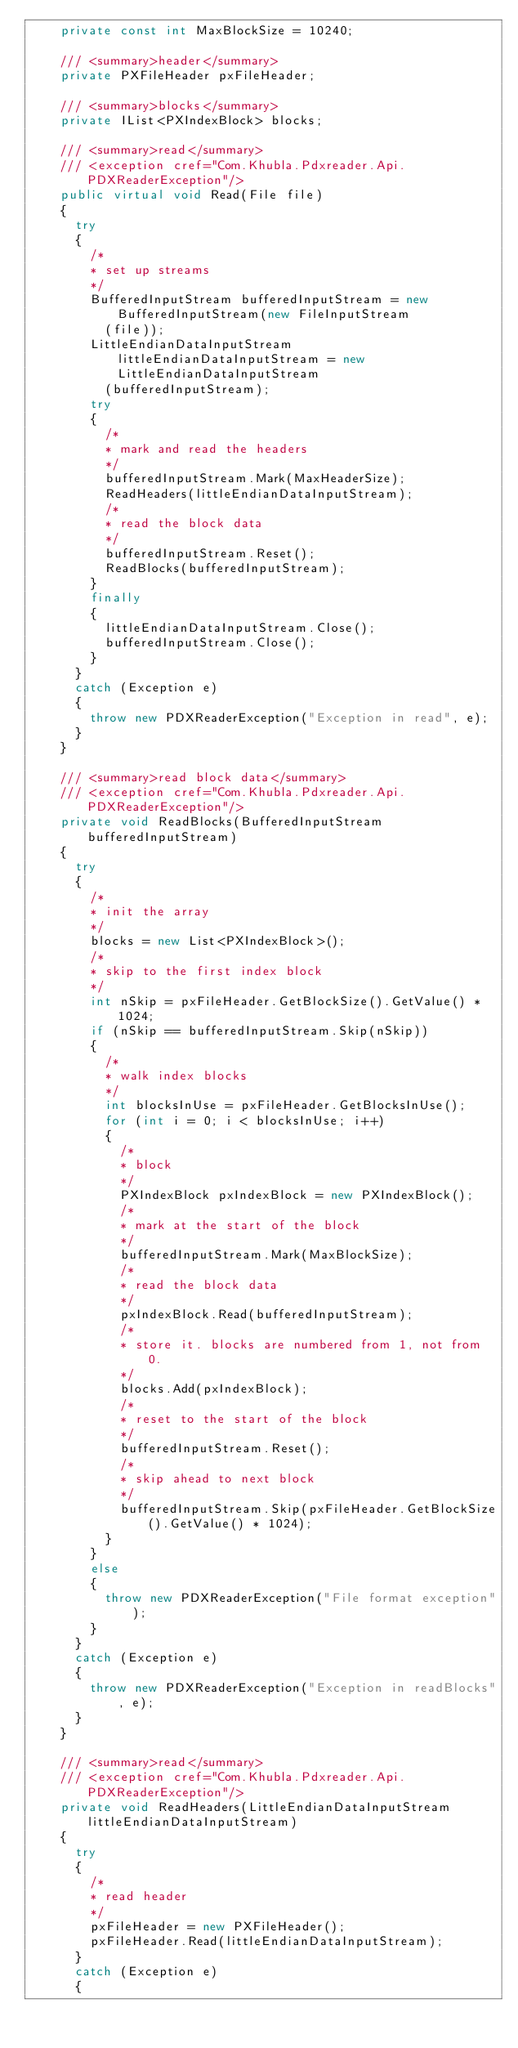<code> <loc_0><loc_0><loc_500><loc_500><_C#_>		private const int MaxBlockSize = 10240;

		/// <summary>header</summary>
		private PXFileHeader pxFileHeader;

		/// <summary>blocks</summary>
		private IList<PXIndexBlock> blocks;

		/// <summary>read</summary>
		/// <exception cref="Com.Khubla.Pdxreader.Api.PDXReaderException"/>
		public virtual void Read(File file)
		{
			try
			{
				/*
				* set up streams
				*/
				BufferedInputStream bufferedInputStream = new BufferedInputStream(new FileInputStream
					(file));
				LittleEndianDataInputStream littleEndianDataInputStream = new LittleEndianDataInputStream
					(bufferedInputStream);
				try
				{
					/*
					* mark and read the headers
					*/
					bufferedInputStream.Mark(MaxHeaderSize);
					ReadHeaders(littleEndianDataInputStream);
					/*
					* read the block data
					*/
					bufferedInputStream.Reset();
					ReadBlocks(bufferedInputStream);
				}
				finally
				{
					littleEndianDataInputStream.Close();
					bufferedInputStream.Close();
				}
			}
			catch (Exception e)
			{
				throw new PDXReaderException("Exception in read", e);
			}
		}

		/// <summary>read block data</summary>
		/// <exception cref="Com.Khubla.Pdxreader.Api.PDXReaderException"/>
		private void ReadBlocks(BufferedInputStream bufferedInputStream)
		{
			try
			{
				/*
				* init the array
				*/
				blocks = new List<PXIndexBlock>();
				/*
				* skip to the first index block
				*/
				int nSkip = pxFileHeader.GetBlockSize().GetValue() * 1024;
				if (nSkip == bufferedInputStream.Skip(nSkip))
				{
					/*
					* walk index blocks
					*/
					int blocksInUse = pxFileHeader.GetBlocksInUse();
					for (int i = 0; i < blocksInUse; i++)
					{
						/*
						* block
						*/
						PXIndexBlock pxIndexBlock = new PXIndexBlock();
						/*
						* mark at the start of the block
						*/
						bufferedInputStream.Mark(MaxBlockSize);
						/*
						* read the block data
						*/
						pxIndexBlock.Read(bufferedInputStream);
						/*
						* store it. blocks are numbered from 1, not from 0.
						*/
						blocks.Add(pxIndexBlock);
						/*
						* reset to the start of the block
						*/
						bufferedInputStream.Reset();
						/*
						* skip ahead to next block
						*/
						bufferedInputStream.Skip(pxFileHeader.GetBlockSize().GetValue() * 1024);
					}
				}
				else
				{
					throw new PDXReaderException("File format exception");
				}
			}
			catch (Exception e)
			{
				throw new PDXReaderException("Exception in readBlocks", e);
			}
		}

		/// <summary>read</summary>
		/// <exception cref="Com.Khubla.Pdxreader.Api.PDXReaderException"/>
		private void ReadHeaders(LittleEndianDataInputStream littleEndianDataInputStream)
		{
			try
			{
				/*
				* read header
				*/
				pxFileHeader = new PXFileHeader();
				pxFileHeader.Read(littleEndianDataInputStream);
			}
			catch (Exception e)
			{</code> 